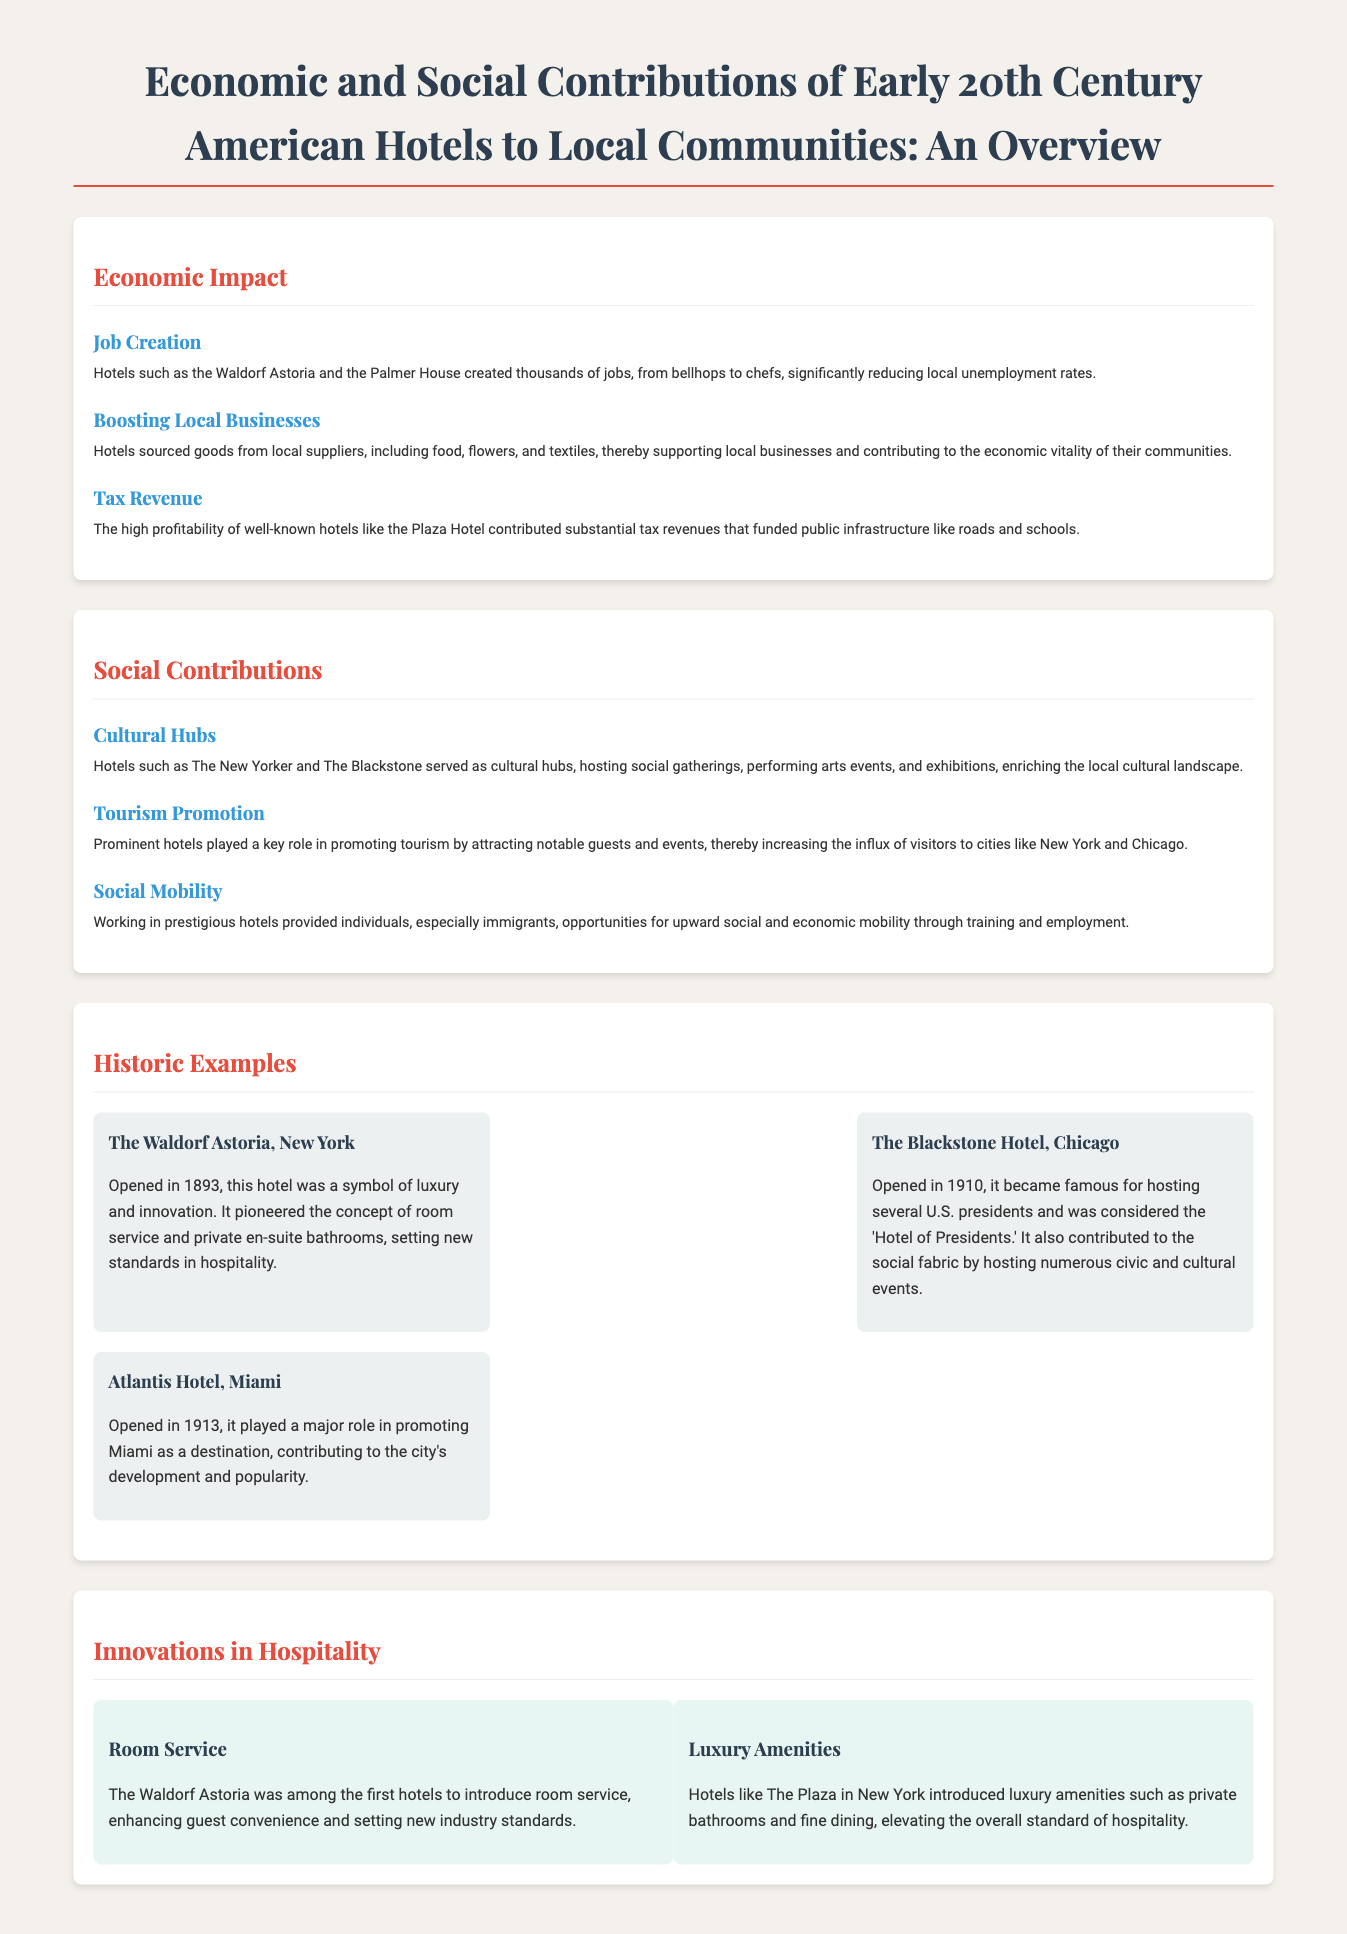What is the main title of the document? The title of the document is provided at the top and summarizes the focus on American hotels in the early 20th century.
Answer: Economic and Social Contributions of Early 20th Century American Hotels to Local Communities: An Overview Which hotel is mentioned as a job creator in New York? The document lists specific hotels that created jobs, highlighting the Waldorf Astoria as one example.
Answer: Waldorf Astoria What year did the Blackstone Hotel open? The document provides specific opening years for several hotels, with the Blackstone Hotel mentioned as opening in 1910.
Answer: 1910 What was the main role of hotels in promoting tourism? The document states that prominent hotels attracted notable guests and events, increasing visitors to cities.
Answer: Attracting notable guests and events Name one innovation in hospitality introduced by the Waldorf Astoria. The document lists innovations and specifies room service as one of the early innovations by the Waldorf Astoria.
Answer: Room Service What impact did hotels have on local businesses? The document notes that hotels supported local businesses by sourcing goods from local suppliers.
Answer: Supported local businesses Which hotel was considered the 'Hotel of Presidents'? The Blackstone Hotel, as noted in the document, became known for hosting several U.S. presidents.
Answer: The Blackstone Hotel What luxurious amenities were introduced by The Plaza? The document mentions luxury amenities introduced by The Plaza, highlighting private bathrooms as one example.
Answer: Private bathrooms How did working in hotels benefit immigrants? The document explains that working in prestigious hotels offered opportunities for upward social and economic mobility.
Answer: Upward social and economic mobility 